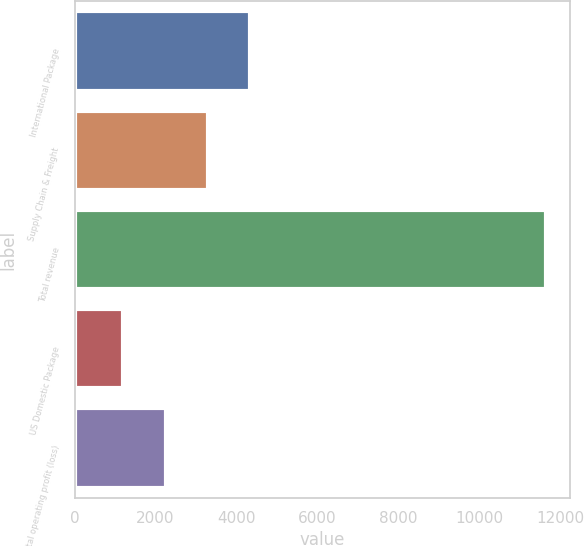Convert chart to OTSL. <chart><loc_0><loc_0><loc_500><loc_500><bar_chart><fcel>International Package<fcel>Supply Chain & Freight<fcel>Total revenue<fcel>US Domestic Package<fcel>Total operating profit (loss)<nl><fcel>4344.2<fcel>3298.8<fcel>11662<fcel>1208<fcel>2253.4<nl></chart> 